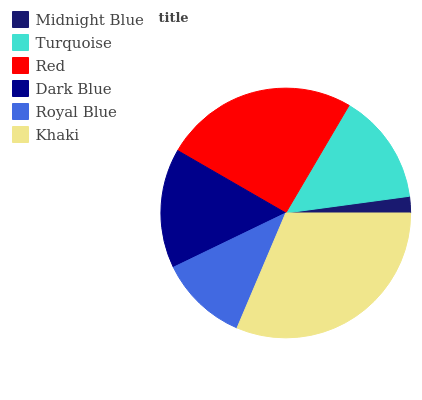Is Midnight Blue the minimum?
Answer yes or no. Yes. Is Khaki the maximum?
Answer yes or no. Yes. Is Turquoise the minimum?
Answer yes or no. No. Is Turquoise the maximum?
Answer yes or no. No. Is Turquoise greater than Midnight Blue?
Answer yes or no. Yes. Is Midnight Blue less than Turquoise?
Answer yes or no. Yes. Is Midnight Blue greater than Turquoise?
Answer yes or no. No. Is Turquoise less than Midnight Blue?
Answer yes or no. No. Is Dark Blue the high median?
Answer yes or no. Yes. Is Turquoise the low median?
Answer yes or no. Yes. Is Turquoise the high median?
Answer yes or no. No. Is Midnight Blue the low median?
Answer yes or no. No. 